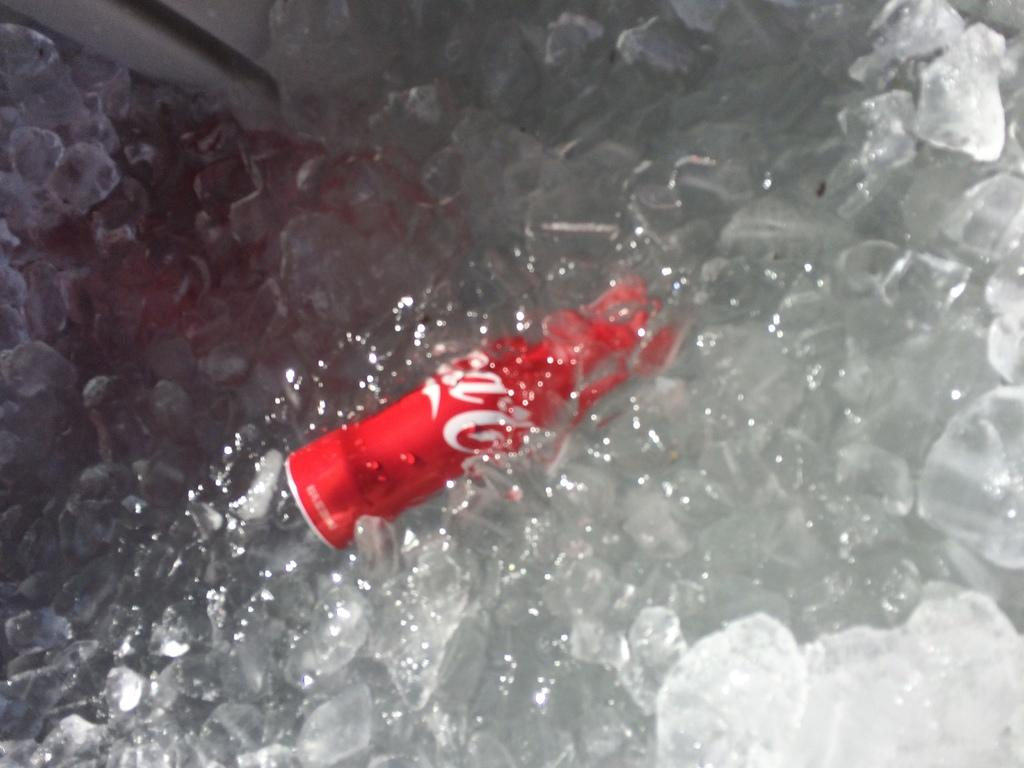What type of frozen water is present in the image? There are ice cubes in the image. What object is placed within the ice cubes? There is a tin inside the ice cubes. How many geese are crossing the bridge in the image? There is no bridge or geese present in the image. 